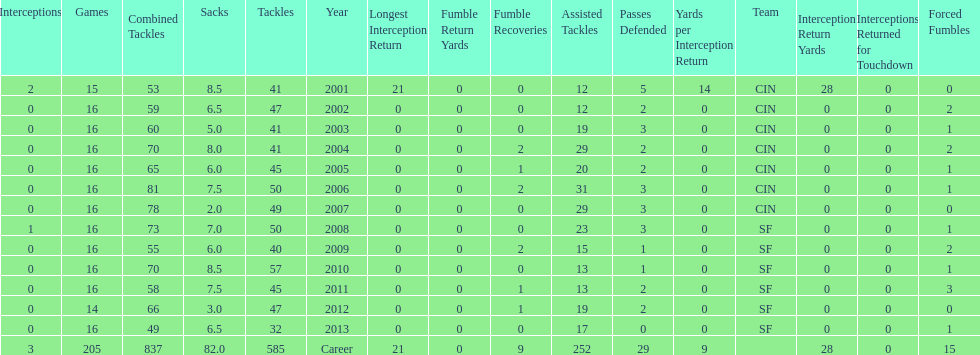How many consecutive years were there 20 or more assisted tackles? 5. 